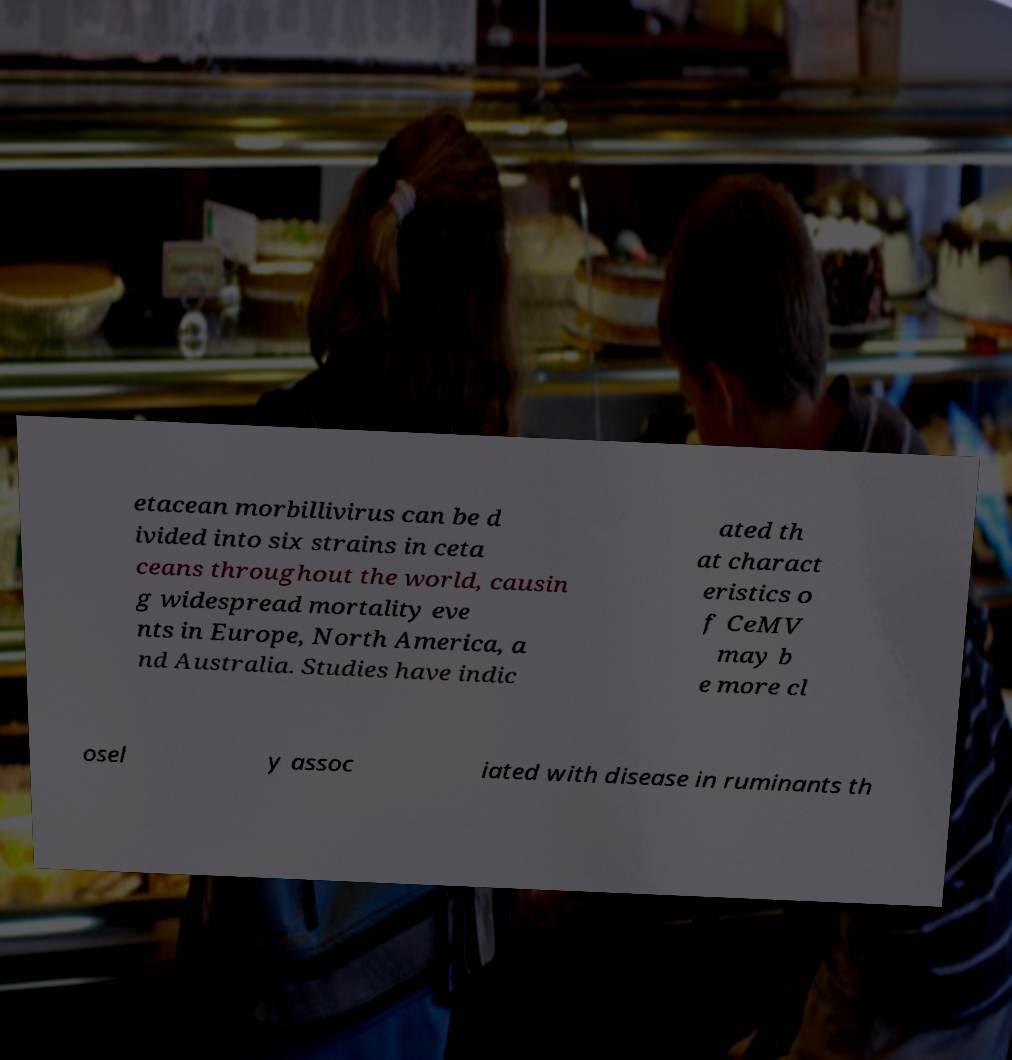I need the written content from this picture converted into text. Can you do that? etacean morbillivirus can be d ivided into six strains in ceta ceans throughout the world, causin g widespread mortality eve nts in Europe, North America, a nd Australia. Studies have indic ated th at charact eristics o f CeMV may b e more cl osel y assoc iated with disease in ruminants th 